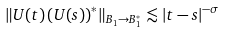<formula> <loc_0><loc_0><loc_500><loc_500>\left \| U ( t ) \left ( U ( s ) \right ) ^ { * } \right \| _ { B _ { 1 } \rightarrow B _ { 1 } ^ { * } } \lesssim | t - s | ^ { - \sigma }</formula> 